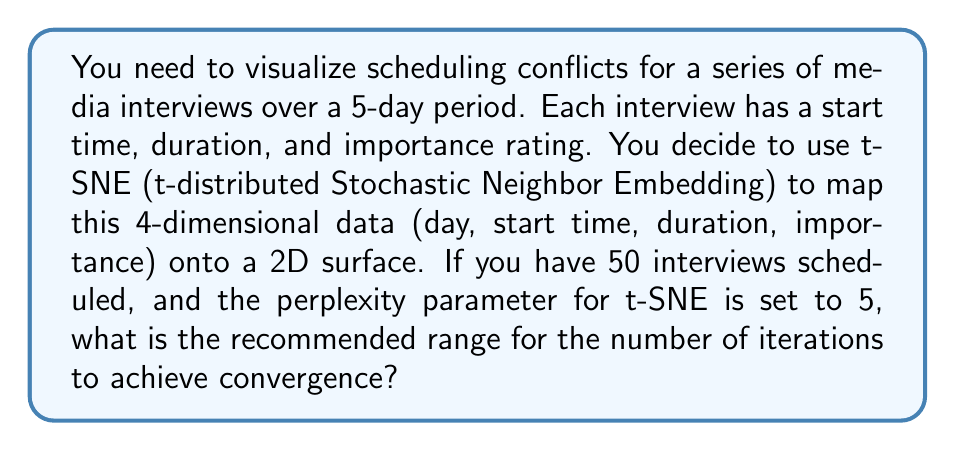What is the answer to this math problem? To determine the recommended range for the number of iterations in t-SNE, we need to consider several factors:

1. Dimensionality of the data:
   Our original data is 4-dimensional (day, start time, duration, importance).

2. Number of data points:
   We have 50 interviews scheduled.

3. Perplexity:
   The perplexity parameter is set to 5.

4. General guidelines for t-SNE:
   - The number of iterations typically ranges from 250 to 1000.
   - More complex datasets often require more iterations.
   - The rule of thumb is to use at least 10 times the number of data points as iterations.

5. Calculation:
   Minimum recommended iterations = 10 * number of data points
   $$ \text{Min iterations} = 10 * 50 = 500 $$

   Maximum recommended iterations:
   Given the relatively low dimensionality and perplexity, we can use the upper end of the typical range, which is 1000.

Therefore, the recommended range for the number of iterations is 500 to 1000.

This range allows for sufficient exploration of the data structure while avoiding excessive computational time. The lower bound ensures that each data point has been adequately considered, while the upper bound provides room for fine-tuning the embedding without risking overfitting.
Answer: The recommended range for the number of iterations is 500 to 1000. 